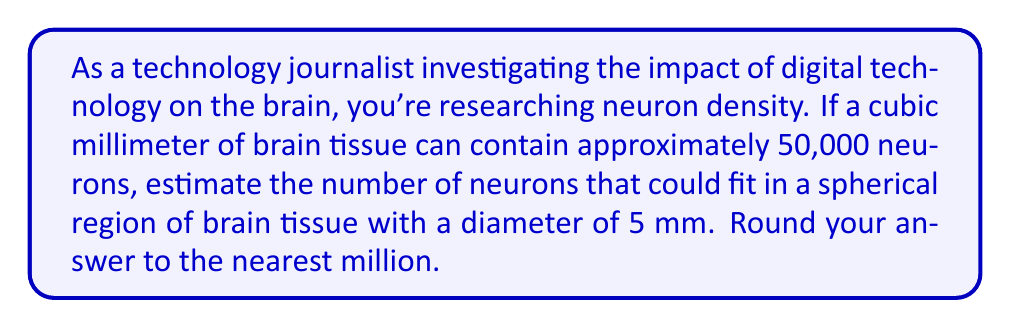Teach me how to tackle this problem. Let's approach this problem step-by-step:

1) First, we need to calculate the volume of the spherical region:
   The volume of a sphere is given by the formula: $V = \frac{4}{3}\pi r^3$
   Where r is the radius, which is half the diameter.

   $r = 5 \text{ mm} \div 2 = 2.5 \text{ mm}$

   $V = \frac{4}{3}\pi (2.5)^3 = \frac{4}{3}\pi (15.625) \approx 65.4498 \text{ mm}^3$

2) Now, we know that 1 cubic millimeter contains 50,000 neurons.
   So, we can set up a proportion:

   $\frac{50,000 \text{ neurons}}{1 \text{ mm}^3} = \frac{x \text{ neurons}}{65.4498 \text{ mm}^3}$

3) Cross multiply and solve for x:

   $x = 50,000 \times 65.4498 = 3,272,490 \text{ neurons}$

4) Rounding to the nearest million:

   3,272,490 rounds to 3,000,000 or 3 million neurons.
Answer: 3 million neurons 